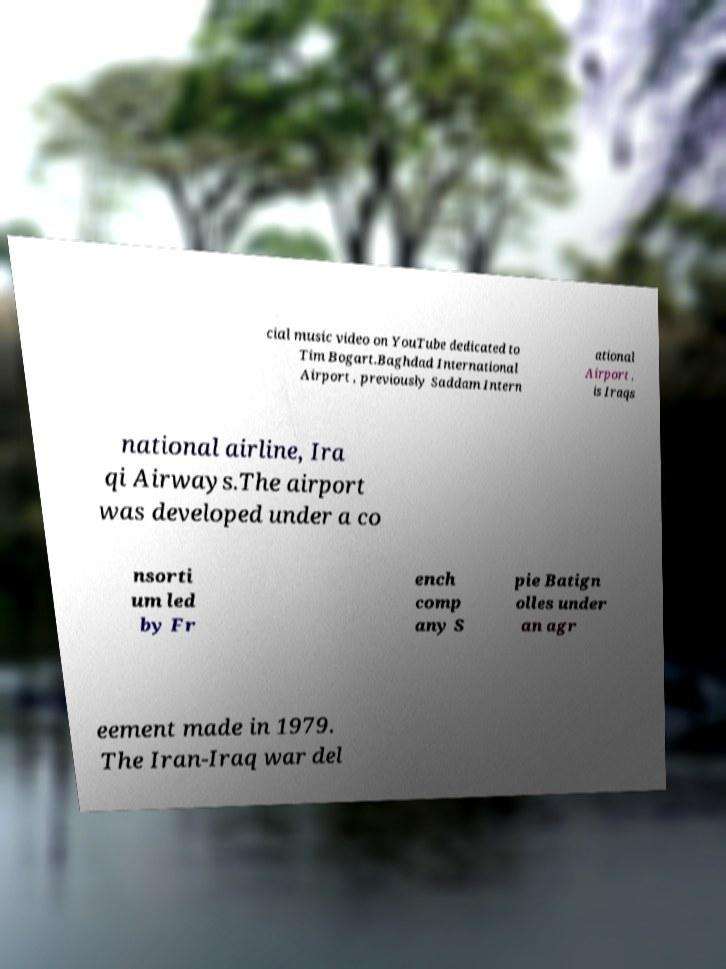I need the written content from this picture converted into text. Can you do that? cial music video on YouTube dedicated to Tim Bogart.Baghdad International Airport , previously Saddam Intern ational Airport , is Iraqs national airline, Ira qi Airways.The airport was developed under a co nsorti um led by Fr ench comp any S pie Batign olles under an agr eement made in 1979. The Iran-Iraq war del 